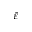<formula> <loc_0><loc_0><loc_500><loc_500>\bar { \varepsilon }</formula> 